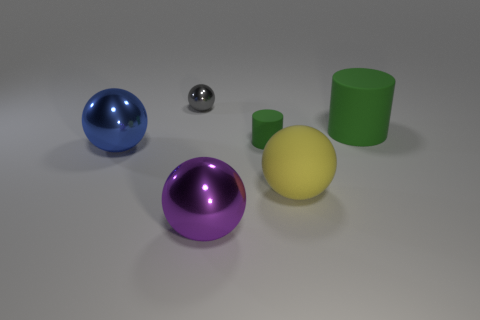There is a tiny object that is right of the gray shiny ball; what is its shape?
Your response must be concise. Cylinder. There is a gray ball that is the same material as the big blue ball; what is its size?
Your response must be concise. Small. What number of other shiny objects have the same shape as the gray metallic object?
Give a very brief answer. 2. Is the color of the small thing behind the small cylinder the same as the rubber sphere?
Your answer should be very brief. No. How many metallic spheres are in front of the big yellow sphere on the right side of the metal thing in front of the large blue sphere?
Provide a succinct answer. 1. What number of big balls are both left of the tiny cylinder and in front of the big blue ball?
Your answer should be very brief. 1. Are there any other things that have the same material as the gray object?
Your answer should be compact. Yes. Do the big green object and the big blue ball have the same material?
Keep it short and to the point. No. What is the shape of the rubber object in front of the rubber cylinder that is left of the rubber object that is on the right side of the yellow rubber thing?
Your response must be concise. Sphere. Are there fewer tiny metallic balls in front of the yellow rubber thing than small green rubber cylinders that are right of the tiny metallic thing?
Offer a terse response. Yes. 